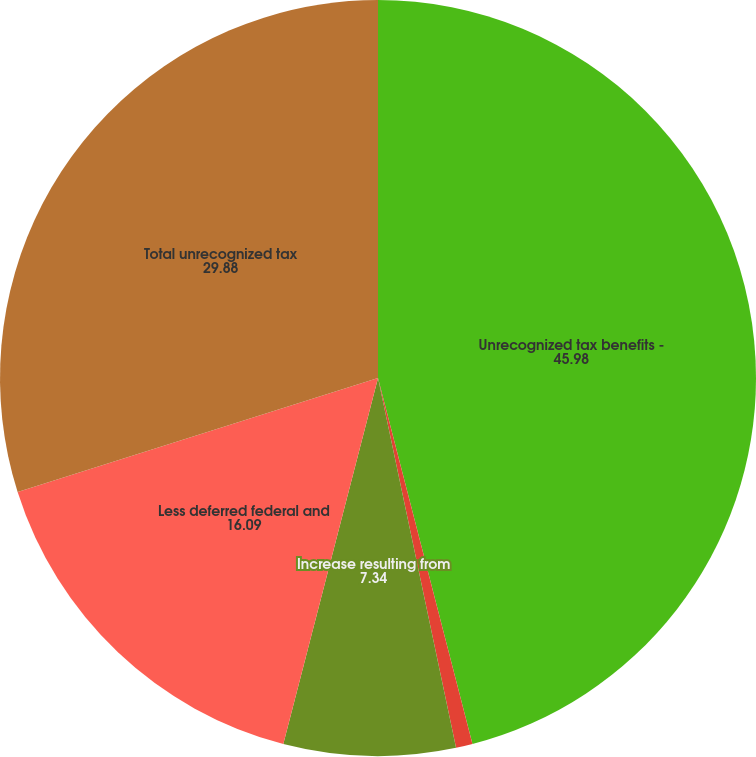Convert chart to OTSL. <chart><loc_0><loc_0><loc_500><loc_500><pie_chart><fcel>Unrecognized tax benefits -<fcel>Increase (decrease) resulting<fcel>Increase resulting from<fcel>Less deferred federal and<fcel>Total unrecognized tax<nl><fcel>45.98%<fcel>0.71%<fcel>7.34%<fcel>16.09%<fcel>29.88%<nl></chart> 